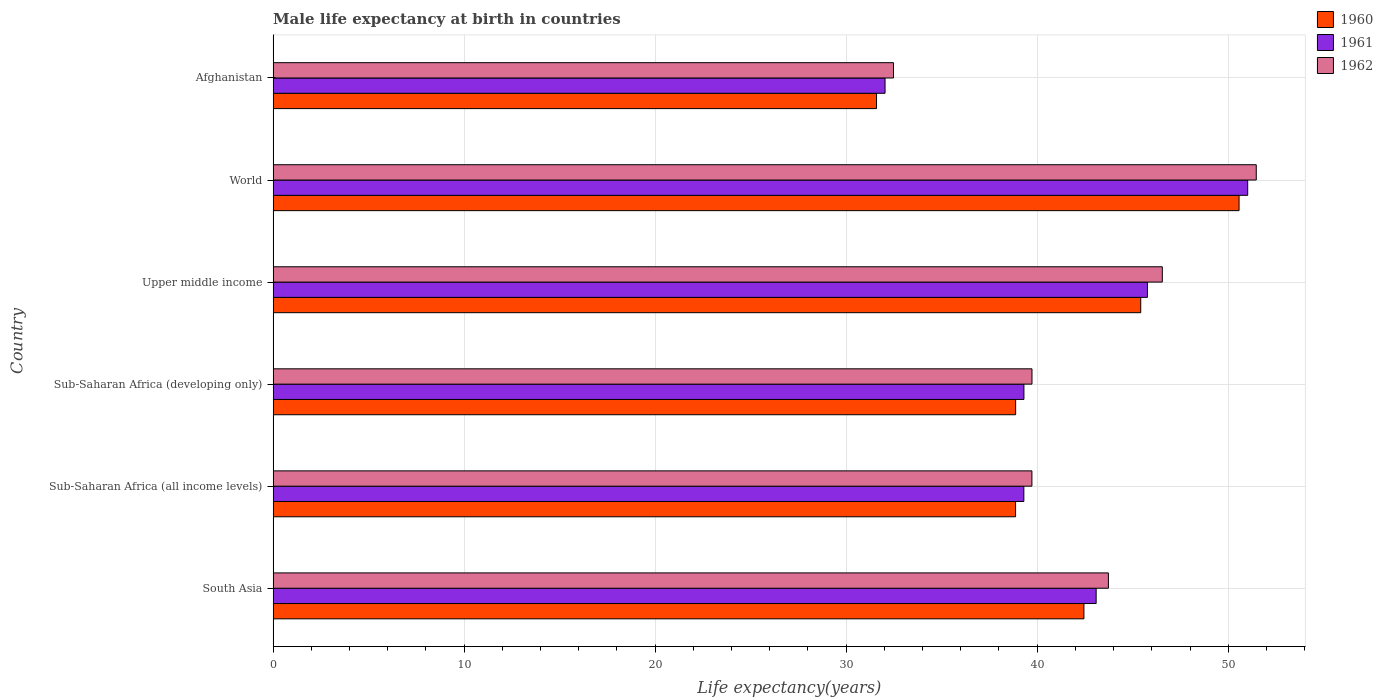How many different coloured bars are there?
Your answer should be very brief. 3. How many bars are there on the 5th tick from the bottom?
Keep it short and to the point. 3. What is the label of the 3rd group of bars from the top?
Ensure brevity in your answer.  Upper middle income. What is the male life expectancy at birth in 1962 in Sub-Saharan Africa (all income levels)?
Provide a succinct answer. 39.72. Across all countries, what is the maximum male life expectancy at birth in 1960?
Keep it short and to the point. 50.57. Across all countries, what is the minimum male life expectancy at birth in 1960?
Provide a succinct answer. 31.59. In which country was the male life expectancy at birth in 1960 minimum?
Keep it short and to the point. Afghanistan. What is the total male life expectancy at birth in 1961 in the graph?
Provide a succinct answer. 250.52. What is the difference between the male life expectancy at birth in 1962 in Afghanistan and that in South Asia?
Your response must be concise. -11.25. What is the difference between the male life expectancy at birth in 1960 in Upper middle income and the male life expectancy at birth in 1961 in Sub-Saharan Africa (all income levels)?
Provide a succinct answer. 6.12. What is the average male life expectancy at birth in 1962 per country?
Give a very brief answer. 42.28. What is the difference between the male life expectancy at birth in 1961 and male life expectancy at birth in 1960 in Sub-Saharan Africa (developing only)?
Make the answer very short. 0.43. What is the ratio of the male life expectancy at birth in 1962 in Upper middle income to that in World?
Your answer should be very brief. 0.9. What is the difference between the highest and the second highest male life expectancy at birth in 1960?
Provide a short and direct response. 5.15. What is the difference between the highest and the lowest male life expectancy at birth in 1962?
Keep it short and to the point. 18.99. Is the sum of the male life expectancy at birth in 1960 in Sub-Saharan Africa (all income levels) and World greater than the maximum male life expectancy at birth in 1961 across all countries?
Provide a succinct answer. Yes. What does the 2nd bar from the top in South Asia represents?
Ensure brevity in your answer.  1961. What does the 3rd bar from the bottom in World represents?
Ensure brevity in your answer.  1962. Is it the case that in every country, the sum of the male life expectancy at birth in 1960 and male life expectancy at birth in 1961 is greater than the male life expectancy at birth in 1962?
Ensure brevity in your answer.  Yes. Are all the bars in the graph horizontal?
Offer a very short reply. Yes. What is the difference between two consecutive major ticks on the X-axis?
Offer a terse response. 10. Are the values on the major ticks of X-axis written in scientific E-notation?
Make the answer very short. No. Where does the legend appear in the graph?
Your answer should be very brief. Top right. How are the legend labels stacked?
Give a very brief answer. Vertical. What is the title of the graph?
Make the answer very short. Male life expectancy at birth in countries. What is the label or title of the X-axis?
Keep it short and to the point. Life expectancy(years). What is the label or title of the Y-axis?
Keep it short and to the point. Country. What is the Life expectancy(years) of 1960 in South Asia?
Offer a very short reply. 42.45. What is the Life expectancy(years) in 1961 in South Asia?
Offer a very short reply. 43.09. What is the Life expectancy(years) in 1962 in South Asia?
Your response must be concise. 43.73. What is the Life expectancy(years) in 1960 in Sub-Saharan Africa (all income levels)?
Give a very brief answer. 38.87. What is the Life expectancy(years) in 1961 in Sub-Saharan Africa (all income levels)?
Your answer should be very brief. 39.3. What is the Life expectancy(years) in 1962 in Sub-Saharan Africa (all income levels)?
Your answer should be very brief. 39.72. What is the Life expectancy(years) of 1960 in Sub-Saharan Africa (developing only)?
Provide a short and direct response. 38.87. What is the Life expectancy(years) in 1961 in Sub-Saharan Africa (developing only)?
Make the answer very short. 39.31. What is the Life expectancy(years) of 1962 in Sub-Saharan Africa (developing only)?
Provide a short and direct response. 39.73. What is the Life expectancy(years) of 1960 in Upper middle income?
Provide a short and direct response. 45.42. What is the Life expectancy(years) in 1961 in Upper middle income?
Your response must be concise. 45.77. What is the Life expectancy(years) in 1962 in Upper middle income?
Provide a succinct answer. 46.55. What is the Life expectancy(years) of 1960 in World?
Offer a terse response. 50.57. What is the Life expectancy(years) of 1961 in World?
Offer a very short reply. 51.02. What is the Life expectancy(years) of 1962 in World?
Offer a terse response. 51.47. What is the Life expectancy(years) of 1960 in Afghanistan?
Provide a succinct answer. 31.59. What is the Life expectancy(years) of 1961 in Afghanistan?
Your answer should be very brief. 32.03. What is the Life expectancy(years) in 1962 in Afghanistan?
Offer a very short reply. 32.48. Across all countries, what is the maximum Life expectancy(years) in 1960?
Make the answer very short. 50.57. Across all countries, what is the maximum Life expectancy(years) of 1961?
Your response must be concise. 51.02. Across all countries, what is the maximum Life expectancy(years) of 1962?
Give a very brief answer. 51.47. Across all countries, what is the minimum Life expectancy(years) in 1960?
Your response must be concise. 31.59. Across all countries, what is the minimum Life expectancy(years) of 1961?
Make the answer very short. 32.03. Across all countries, what is the minimum Life expectancy(years) in 1962?
Provide a succinct answer. 32.48. What is the total Life expectancy(years) of 1960 in the graph?
Make the answer very short. 247.76. What is the total Life expectancy(years) in 1961 in the graph?
Provide a succinct answer. 250.52. What is the total Life expectancy(years) of 1962 in the graph?
Your answer should be very brief. 253.67. What is the difference between the Life expectancy(years) in 1960 in South Asia and that in Sub-Saharan Africa (all income levels)?
Provide a succinct answer. 3.58. What is the difference between the Life expectancy(years) in 1961 in South Asia and that in Sub-Saharan Africa (all income levels)?
Ensure brevity in your answer.  3.79. What is the difference between the Life expectancy(years) in 1962 in South Asia and that in Sub-Saharan Africa (all income levels)?
Your response must be concise. 4. What is the difference between the Life expectancy(years) of 1960 in South Asia and that in Sub-Saharan Africa (developing only)?
Provide a short and direct response. 3.57. What is the difference between the Life expectancy(years) of 1961 in South Asia and that in Sub-Saharan Africa (developing only)?
Provide a succinct answer. 3.78. What is the difference between the Life expectancy(years) of 1962 in South Asia and that in Sub-Saharan Africa (developing only)?
Give a very brief answer. 4. What is the difference between the Life expectancy(years) of 1960 in South Asia and that in Upper middle income?
Provide a succinct answer. -2.97. What is the difference between the Life expectancy(years) in 1961 in South Asia and that in Upper middle income?
Your response must be concise. -2.68. What is the difference between the Life expectancy(years) of 1962 in South Asia and that in Upper middle income?
Ensure brevity in your answer.  -2.82. What is the difference between the Life expectancy(years) in 1960 in South Asia and that in World?
Offer a very short reply. -8.12. What is the difference between the Life expectancy(years) of 1961 in South Asia and that in World?
Provide a succinct answer. -7.93. What is the difference between the Life expectancy(years) in 1962 in South Asia and that in World?
Give a very brief answer. -7.74. What is the difference between the Life expectancy(years) in 1960 in South Asia and that in Afghanistan?
Your answer should be very brief. 10.86. What is the difference between the Life expectancy(years) in 1961 in South Asia and that in Afghanistan?
Provide a succinct answer. 11.05. What is the difference between the Life expectancy(years) of 1962 in South Asia and that in Afghanistan?
Offer a terse response. 11.25. What is the difference between the Life expectancy(years) of 1960 in Sub-Saharan Africa (all income levels) and that in Sub-Saharan Africa (developing only)?
Your response must be concise. -0. What is the difference between the Life expectancy(years) in 1961 in Sub-Saharan Africa (all income levels) and that in Sub-Saharan Africa (developing only)?
Offer a terse response. -0. What is the difference between the Life expectancy(years) of 1962 in Sub-Saharan Africa (all income levels) and that in Sub-Saharan Africa (developing only)?
Give a very brief answer. -0. What is the difference between the Life expectancy(years) of 1960 in Sub-Saharan Africa (all income levels) and that in Upper middle income?
Offer a terse response. -6.55. What is the difference between the Life expectancy(years) of 1961 in Sub-Saharan Africa (all income levels) and that in Upper middle income?
Ensure brevity in your answer.  -6.47. What is the difference between the Life expectancy(years) in 1962 in Sub-Saharan Africa (all income levels) and that in Upper middle income?
Your response must be concise. -6.83. What is the difference between the Life expectancy(years) in 1960 in Sub-Saharan Africa (all income levels) and that in World?
Give a very brief answer. -11.7. What is the difference between the Life expectancy(years) of 1961 in Sub-Saharan Africa (all income levels) and that in World?
Your answer should be very brief. -11.72. What is the difference between the Life expectancy(years) in 1962 in Sub-Saharan Africa (all income levels) and that in World?
Provide a succinct answer. -11.75. What is the difference between the Life expectancy(years) in 1960 in Sub-Saharan Africa (all income levels) and that in Afghanistan?
Keep it short and to the point. 7.28. What is the difference between the Life expectancy(years) in 1961 in Sub-Saharan Africa (all income levels) and that in Afghanistan?
Provide a succinct answer. 7.27. What is the difference between the Life expectancy(years) in 1962 in Sub-Saharan Africa (all income levels) and that in Afghanistan?
Your answer should be very brief. 7.25. What is the difference between the Life expectancy(years) in 1960 in Sub-Saharan Africa (developing only) and that in Upper middle income?
Provide a short and direct response. -6.55. What is the difference between the Life expectancy(years) of 1961 in Sub-Saharan Africa (developing only) and that in Upper middle income?
Provide a succinct answer. -6.47. What is the difference between the Life expectancy(years) of 1962 in Sub-Saharan Africa (developing only) and that in Upper middle income?
Your response must be concise. -6.82. What is the difference between the Life expectancy(years) of 1960 in Sub-Saharan Africa (developing only) and that in World?
Offer a very short reply. -11.7. What is the difference between the Life expectancy(years) of 1961 in Sub-Saharan Africa (developing only) and that in World?
Your answer should be compact. -11.71. What is the difference between the Life expectancy(years) of 1962 in Sub-Saharan Africa (developing only) and that in World?
Give a very brief answer. -11.74. What is the difference between the Life expectancy(years) of 1960 in Sub-Saharan Africa (developing only) and that in Afghanistan?
Ensure brevity in your answer.  7.28. What is the difference between the Life expectancy(years) of 1961 in Sub-Saharan Africa (developing only) and that in Afghanistan?
Provide a short and direct response. 7.27. What is the difference between the Life expectancy(years) of 1962 in Sub-Saharan Africa (developing only) and that in Afghanistan?
Your answer should be compact. 7.25. What is the difference between the Life expectancy(years) in 1960 in Upper middle income and that in World?
Offer a terse response. -5.15. What is the difference between the Life expectancy(years) in 1961 in Upper middle income and that in World?
Keep it short and to the point. -5.25. What is the difference between the Life expectancy(years) of 1962 in Upper middle income and that in World?
Provide a succinct answer. -4.92. What is the difference between the Life expectancy(years) of 1960 in Upper middle income and that in Afghanistan?
Give a very brief answer. 13.83. What is the difference between the Life expectancy(years) of 1961 in Upper middle income and that in Afghanistan?
Offer a terse response. 13.74. What is the difference between the Life expectancy(years) of 1962 in Upper middle income and that in Afghanistan?
Provide a short and direct response. 14.07. What is the difference between the Life expectancy(years) of 1960 in World and that in Afghanistan?
Your answer should be very brief. 18.98. What is the difference between the Life expectancy(years) in 1961 in World and that in Afghanistan?
Provide a short and direct response. 18.98. What is the difference between the Life expectancy(years) in 1962 in World and that in Afghanistan?
Ensure brevity in your answer.  18.99. What is the difference between the Life expectancy(years) in 1960 in South Asia and the Life expectancy(years) in 1961 in Sub-Saharan Africa (all income levels)?
Ensure brevity in your answer.  3.15. What is the difference between the Life expectancy(years) in 1960 in South Asia and the Life expectancy(years) in 1962 in Sub-Saharan Africa (all income levels)?
Your answer should be very brief. 2.72. What is the difference between the Life expectancy(years) of 1961 in South Asia and the Life expectancy(years) of 1962 in Sub-Saharan Africa (all income levels)?
Ensure brevity in your answer.  3.36. What is the difference between the Life expectancy(years) of 1960 in South Asia and the Life expectancy(years) of 1961 in Sub-Saharan Africa (developing only)?
Provide a succinct answer. 3.14. What is the difference between the Life expectancy(years) of 1960 in South Asia and the Life expectancy(years) of 1962 in Sub-Saharan Africa (developing only)?
Offer a very short reply. 2.72. What is the difference between the Life expectancy(years) in 1961 in South Asia and the Life expectancy(years) in 1962 in Sub-Saharan Africa (developing only)?
Provide a short and direct response. 3.36. What is the difference between the Life expectancy(years) in 1960 in South Asia and the Life expectancy(years) in 1961 in Upper middle income?
Provide a short and direct response. -3.32. What is the difference between the Life expectancy(years) in 1960 in South Asia and the Life expectancy(years) in 1962 in Upper middle income?
Your response must be concise. -4.1. What is the difference between the Life expectancy(years) of 1961 in South Asia and the Life expectancy(years) of 1962 in Upper middle income?
Give a very brief answer. -3.46. What is the difference between the Life expectancy(years) in 1960 in South Asia and the Life expectancy(years) in 1961 in World?
Your answer should be compact. -8.57. What is the difference between the Life expectancy(years) of 1960 in South Asia and the Life expectancy(years) of 1962 in World?
Give a very brief answer. -9.02. What is the difference between the Life expectancy(years) in 1961 in South Asia and the Life expectancy(years) in 1962 in World?
Provide a succinct answer. -8.38. What is the difference between the Life expectancy(years) in 1960 in South Asia and the Life expectancy(years) in 1961 in Afghanistan?
Provide a short and direct response. 10.41. What is the difference between the Life expectancy(years) of 1960 in South Asia and the Life expectancy(years) of 1962 in Afghanistan?
Your answer should be very brief. 9.97. What is the difference between the Life expectancy(years) of 1961 in South Asia and the Life expectancy(years) of 1962 in Afghanistan?
Your answer should be compact. 10.61. What is the difference between the Life expectancy(years) in 1960 in Sub-Saharan Africa (all income levels) and the Life expectancy(years) in 1961 in Sub-Saharan Africa (developing only)?
Your answer should be very brief. -0.44. What is the difference between the Life expectancy(years) of 1960 in Sub-Saharan Africa (all income levels) and the Life expectancy(years) of 1962 in Sub-Saharan Africa (developing only)?
Provide a succinct answer. -0.86. What is the difference between the Life expectancy(years) of 1961 in Sub-Saharan Africa (all income levels) and the Life expectancy(years) of 1962 in Sub-Saharan Africa (developing only)?
Make the answer very short. -0.43. What is the difference between the Life expectancy(years) of 1960 in Sub-Saharan Africa (all income levels) and the Life expectancy(years) of 1961 in Upper middle income?
Provide a succinct answer. -6.9. What is the difference between the Life expectancy(years) of 1960 in Sub-Saharan Africa (all income levels) and the Life expectancy(years) of 1962 in Upper middle income?
Make the answer very short. -7.68. What is the difference between the Life expectancy(years) of 1961 in Sub-Saharan Africa (all income levels) and the Life expectancy(years) of 1962 in Upper middle income?
Your answer should be compact. -7.25. What is the difference between the Life expectancy(years) of 1960 in Sub-Saharan Africa (all income levels) and the Life expectancy(years) of 1961 in World?
Your answer should be very brief. -12.15. What is the difference between the Life expectancy(years) in 1960 in Sub-Saharan Africa (all income levels) and the Life expectancy(years) in 1962 in World?
Ensure brevity in your answer.  -12.6. What is the difference between the Life expectancy(years) in 1961 in Sub-Saharan Africa (all income levels) and the Life expectancy(years) in 1962 in World?
Give a very brief answer. -12.17. What is the difference between the Life expectancy(years) in 1960 in Sub-Saharan Africa (all income levels) and the Life expectancy(years) in 1961 in Afghanistan?
Ensure brevity in your answer.  6.83. What is the difference between the Life expectancy(years) in 1960 in Sub-Saharan Africa (all income levels) and the Life expectancy(years) in 1962 in Afghanistan?
Keep it short and to the point. 6.39. What is the difference between the Life expectancy(years) in 1961 in Sub-Saharan Africa (all income levels) and the Life expectancy(years) in 1962 in Afghanistan?
Make the answer very short. 6.83. What is the difference between the Life expectancy(years) of 1960 in Sub-Saharan Africa (developing only) and the Life expectancy(years) of 1961 in Upper middle income?
Provide a short and direct response. -6.9. What is the difference between the Life expectancy(years) in 1960 in Sub-Saharan Africa (developing only) and the Life expectancy(years) in 1962 in Upper middle income?
Offer a terse response. -7.68. What is the difference between the Life expectancy(years) of 1961 in Sub-Saharan Africa (developing only) and the Life expectancy(years) of 1962 in Upper middle income?
Offer a terse response. -7.24. What is the difference between the Life expectancy(years) in 1960 in Sub-Saharan Africa (developing only) and the Life expectancy(years) in 1961 in World?
Ensure brevity in your answer.  -12.15. What is the difference between the Life expectancy(years) of 1960 in Sub-Saharan Africa (developing only) and the Life expectancy(years) of 1962 in World?
Provide a short and direct response. -12.6. What is the difference between the Life expectancy(years) of 1961 in Sub-Saharan Africa (developing only) and the Life expectancy(years) of 1962 in World?
Keep it short and to the point. -12.16. What is the difference between the Life expectancy(years) of 1960 in Sub-Saharan Africa (developing only) and the Life expectancy(years) of 1961 in Afghanistan?
Your answer should be very brief. 6.84. What is the difference between the Life expectancy(years) in 1960 in Sub-Saharan Africa (developing only) and the Life expectancy(years) in 1962 in Afghanistan?
Offer a terse response. 6.4. What is the difference between the Life expectancy(years) of 1961 in Sub-Saharan Africa (developing only) and the Life expectancy(years) of 1962 in Afghanistan?
Your answer should be very brief. 6.83. What is the difference between the Life expectancy(years) of 1960 in Upper middle income and the Life expectancy(years) of 1961 in World?
Offer a terse response. -5.6. What is the difference between the Life expectancy(years) in 1960 in Upper middle income and the Life expectancy(years) in 1962 in World?
Ensure brevity in your answer.  -6.05. What is the difference between the Life expectancy(years) of 1961 in Upper middle income and the Life expectancy(years) of 1962 in World?
Provide a succinct answer. -5.7. What is the difference between the Life expectancy(years) of 1960 in Upper middle income and the Life expectancy(years) of 1961 in Afghanistan?
Your answer should be compact. 13.39. What is the difference between the Life expectancy(years) in 1960 in Upper middle income and the Life expectancy(years) in 1962 in Afghanistan?
Your response must be concise. 12.94. What is the difference between the Life expectancy(years) of 1961 in Upper middle income and the Life expectancy(years) of 1962 in Afghanistan?
Keep it short and to the point. 13.29. What is the difference between the Life expectancy(years) in 1960 in World and the Life expectancy(years) in 1961 in Afghanistan?
Your response must be concise. 18.53. What is the difference between the Life expectancy(years) of 1960 in World and the Life expectancy(years) of 1962 in Afghanistan?
Your response must be concise. 18.09. What is the difference between the Life expectancy(years) of 1961 in World and the Life expectancy(years) of 1962 in Afghanistan?
Make the answer very short. 18.54. What is the average Life expectancy(years) in 1960 per country?
Ensure brevity in your answer.  41.29. What is the average Life expectancy(years) of 1961 per country?
Provide a short and direct response. 41.75. What is the average Life expectancy(years) in 1962 per country?
Offer a terse response. 42.28. What is the difference between the Life expectancy(years) in 1960 and Life expectancy(years) in 1961 in South Asia?
Give a very brief answer. -0.64. What is the difference between the Life expectancy(years) of 1960 and Life expectancy(years) of 1962 in South Asia?
Your answer should be very brief. -1.28. What is the difference between the Life expectancy(years) in 1961 and Life expectancy(years) in 1962 in South Asia?
Your response must be concise. -0.64. What is the difference between the Life expectancy(years) in 1960 and Life expectancy(years) in 1961 in Sub-Saharan Africa (all income levels)?
Provide a succinct answer. -0.43. What is the difference between the Life expectancy(years) in 1960 and Life expectancy(years) in 1962 in Sub-Saharan Africa (all income levels)?
Keep it short and to the point. -0.86. What is the difference between the Life expectancy(years) in 1961 and Life expectancy(years) in 1962 in Sub-Saharan Africa (all income levels)?
Make the answer very short. -0.42. What is the difference between the Life expectancy(years) of 1960 and Life expectancy(years) of 1961 in Sub-Saharan Africa (developing only)?
Provide a succinct answer. -0.43. What is the difference between the Life expectancy(years) of 1960 and Life expectancy(years) of 1962 in Sub-Saharan Africa (developing only)?
Make the answer very short. -0.86. What is the difference between the Life expectancy(years) of 1961 and Life expectancy(years) of 1962 in Sub-Saharan Africa (developing only)?
Ensure brevity in your answer.  -0.42. What is the difference between the Life expectancy(years) in 1960 and Life expectancy(years) in 1961 in Upper middle income?
Give a very brief answer. -0.35. What is the difference between the Life expectancy(years) in 1960 and Life expectancy(years) in 1962 in Upper middle income?
Provide a short and direct response. -1.13. What is the difference between the Life expectancy(years) in 1961 and Life expectancy(years) in 1962 in Upper middle income?
Offer a terse response. -0.78. What is the difference between the Life expectancy(years) of 1960 and Life expectancy(years) of 1961 in World?
Provide a short and direct response. -0.45. What is the difference between the Life expectancy(years) in 1960 and Life expectancy(years) in 1962 in World?
Your answer should be compact. -0.9. What is the difference between the Life expectancy(years) in 1961 and Life expectancy(years) in 1962 in World?
Provide a short and direct response. -0.45. What is the difference between the Life expectancy(years) of 1960 and Life expectancy(years) of 1961 in Afghanistan?
Your answer should be very brief. -0.45. What is the difference between the Life expectancy(years) of 1960 and Life expectancy(years) of 1962 in Afghanistan?
Your answer should be compact. -0.89. What is the difference between the Life expectancy(years) of 1961 and Life expectancy(years) of 1962 in Afghanistan?
Your response must be concise. -0.44. What is the ratio of the Life expectancy(years) of 1960 in South Asia to that in Sub-Saharan Africa (all income levels)?
Give a very brief answer. 1.09. What is the ratio of the Life expectancy(years) of 1961 in South Asia to that in Sub-Saharan Africa (all income levels)?
Ensure brevity in your answer.  1.1. What is the ratio of the Life expectancy(years) of 1962 in South Asia to that in Sub-Saharan Africa (all income levels)?
Your response must be concise. 1.1. What is the ratio of the Life expectancy(years) in 1960 in South Asia to that in Sub-Saharan Africa (developing only)?
Your answer should be very brief. 1.09. What is the ratio of the Life expectancy(years) of 1961 in South Asia to that in Sub-Saharan Africa (developing only)?
Keep it short and to the point. 1.1. What is the ratio of the Life expectancy(years) in 1962 in South Asia to that in Sub-Saharan Africa (developing only)?
Provide a short and direct response. 1.1. What is the ratio of the Life expectancy(years) of 1960 in South Asia to that in Upper middle income?
Provide a succinct answer. 0.93. What is the ratio of the Life expectancy(years) of 1961 in South Asia to that in Upper middle income?
Your response must be concise. 0.94. What is the ratio of the Life expectancy(years) of 1962 in South Asia to that in Upper middle income?
Your response must be concise. 0.94. What is the ratio of the Life expectancy(years) of 1960 in South Asia to that in World?
Give a very brief answer. 0.84. What is the ratio of the Life expectancy(years) of 1961 in South Asia to that in World?
Provide a short and direct response. 0.84. What is the ratio of the Life expectancy(years) of 1962 in South Asia to that in World?
Provide a succinct answer. 0.85. What is the ratio of the Life expectancy(years) in 1960 in South Asia to that in Afghanistan?
Ensure brevity in your answer.  1.34. What is the ratio of the Life expectancy(years) in 1961 in South Asia to that in Afghanistan?
Your response must be concise. 1.34. What is the ratio of the Life expectancy(years) in 1962 in South Asia to that in Afghanistan?
Provide a succinct answer. 1.35. What is the ratio of the Life expectancy(years) of 1961 in Sub-Saharan Africa (all income levels) to that in Sub-Saharan Africa (developing only)?
Make the answer very short. 1. What is the ratio of the Life expectancy(years) of 1962 in Sub-Saharan Africa (all income levels) to that in Sub-Saharan Africa (developing only)?
Keep it short and to the point. 1. What is the ratio of the Life expectancy(years) of 1960 in Sub-Saharan Africa (all income levels) to that in Upper middle income?
Make the answer very short. 0.86. What is the ratio of the Life expectancy(years) of 1961 in Sub-Saharan Africa (all income levels) to that in Upper middle income?
Your response must be concise. 0.86. What is the ratio of the Life expectancy(years) in 1962 in Sub-Saharan Africa (all income levels) to that in Upper middle income?
Your response must be concise. 0.85. What is the ratio of the Life expectancy(years) in 1960 in Sub-Saharan Africa (all income levels) to that in World?
Provide a succinct answer. 0.77. What is the ratio of the Life expectancy(years) in 1961 in Sub-Saharan Africa (all income levels) to that in World?
Offer a very short reply. 0.77. What is the ratio of the Life expectancy(years) of 1962 in Sub-Saharan Africa (all income levels) to that in World?
Offer a very short reply. 0.77. What is the ratio of the Life expectancy(years) in 1960 in Sub-Saharan Africa (all income levels) to that in Afghanistan?
Offer a very short reply. 1.23. What is the ratio of the Life expectancy(years) of 1961 in Sub-Saharan Africa (all income levels) to that in Afghanistan?
Make the answer very short. 1.23. What is the ratio of the Life expectancy(years) in 1962 in Sub-Saharan Africa (all income levels) to that in Afghanistan?
Your answer should be very brief. 1.22. What is the ratio of the Life expectancy(years) of 1960 in Sub-Saharan Africa (developing only) to that in Upper middle income?
Keep it short and to the point. 0.86. What is the ratio of the Life expectancy(years) of 1961 in Sub-Saharan Africa (developing only) to that in Upper middle income?
Offer a terse response. 0.86. What is the ratio of the Life expectancy(years) of 1962 in Sub-Saharan Africa (developing only) to that in Upper middle income?
Your answer should be compact. 0.85. What is the ratio of the Life expectancy(years) in 1960 in Sub-Saharan Africa (developing only) to that in World?
Make the answer very short. 0.77. What is the ratio of the Life expectancy(years) in 1961 in Sub-Saharan Africa (developing only) to that in World?
Offer a very short reply. 0.77. What is the ratio of the Life expectancy(years) in 1962 in Sub-Saharan Africa (developing only) to that in World?
Your answer should be very brief. 0.77. What is the ratio of the Life expectancy(years) in 1960 in Sub-Saharan Africa (developing only) to that in Afghanistan?
Your response must be concise. 1.23. What is the ratio of the Life expectancy(years) of 1961 in Sub-Saharan Africa (developing only) to that in Afghanistan?
Provide a short and direct response. 1.23. What is the ratio of the Life expectancy(years) of 1962 in Sub-Saharan Africa (developing only) to that in Afghanistan?
Keep it short and to the point. 1.22. What is the ratio of the Life expectancy(years) of 1960 in Upper middle income to that in World?
Give a very brief answer. 0.9. What is the ratio of the Life expectancy(years) in 1961 in Upper middle income to that in World?
Your answer should be very brief. 0.9. What is the ratio of the Life expectancy(years) of 1962 in Upper middle income to that in World?
Your response must be concise. 0.9. What is the ratio of the Life expectancy(years) of 1960 in Upper middle income to that in Afghanistan?
Keep it short and to the point. 1.44. What is the ratio of the Life expectancy(years) of 1961 in Upper middle income to that in Afghanistan?
Provide a short and direct response. 1.43. What is the ratio of the Life expectancy(years) in 1962 in Upper middle income to that in Afghanistan?
Provide a succinct answer. 1.43. What is the ratio of the Life expectancy(years) in 1960 in World to that in Afghanistan?
Ensure brevity in your answer.  1.6. What is the ratio of the Life expectancy(years) of 1961 in World to that in Afghanistan?
Give a very brief answer. 1.59. What is the ratio of the Life expectancy(years) in 1962 in World to that in Afghanistan?
Your answer should be compact. 1.58. What is the difference between the highest and the second highest Life expectancy(years) in 1960?
Give a very brief answer. 5.15. What is the difference between the highest and the second highest Life expectancy(years) of 1961?
Keep it short and to the point. 5.25. What is the difference between the highest and the second highest Life expectancy(years) of 1962?
Your answer should be very brief. 4.92. What is the difference between the highest and the lowest Life expectancy(years) of 1960?
Make the answer very short. 18.98. What is the difference between the highest and the lowest Life expectancy(years) in 1961?
Offer a terse response. 18.98. What is the difference between the highest and the lowest Life expectancy(years) of 1962?
Ensure brevity in your answer.  18.99. 